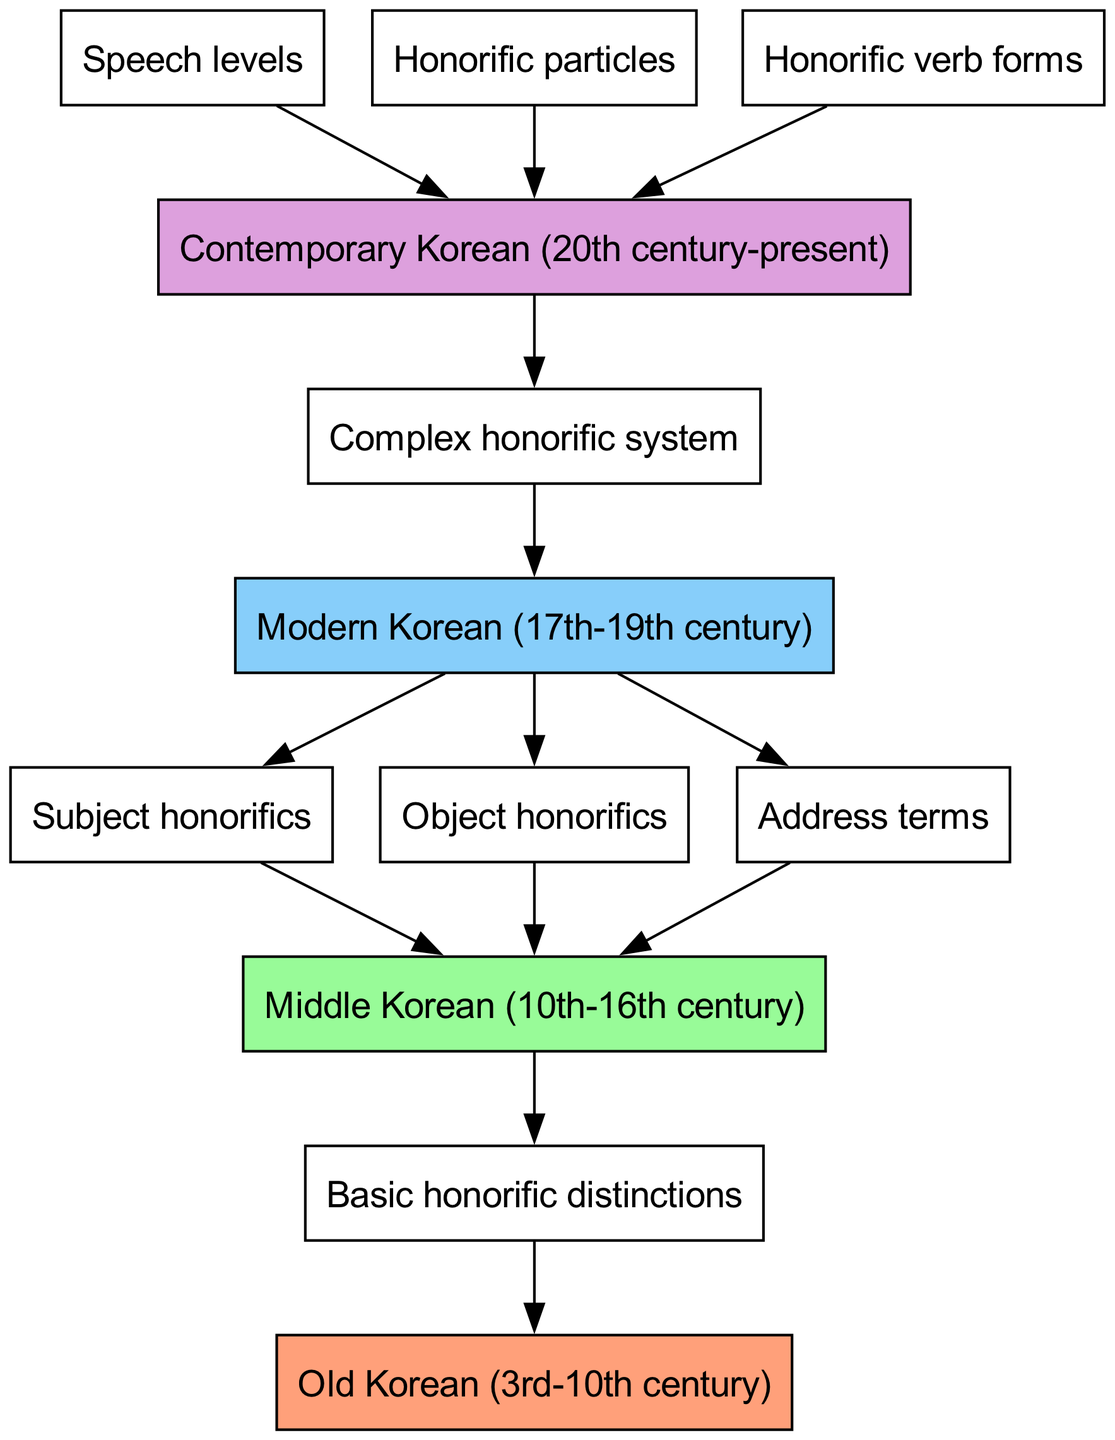What is the time period of Old Korean? Old Korean is identified within the time period of the 3rd to 10th century, which is shown at the top of the flow chart.
Answer: 3rd-10th century Which type of honorifics is introduced in Middle Korean? In Middle Korean, subject honorifics are introduced as shown by the direct connection from Middle Korean to subject honorifics in the diagram.
Answer: Subject honorifics How many distinct stages of development are there from Old Korean to Contemporary Korean? The diagram shows four distinct stages of development: Old Korean, Middle Korean, Modern Korean, and Contemporary Korean, thus totaling four stages.
Answer: 4 What type of honorific system emerges in Modern Korean? The complex honorific system emerges in Modern Korean as indicated by the arrow leading from Modern Korean to complex honorific system in the diagram.
Answer: Complex honorific system What are the two types of honorifics that branch out from Middle Korean? Middle Korean branches out into subject honorifics and object honorifics as indicated by the outgoing connections from Middle Korean, leading to those respective terms.
Answer: Subject and object honorifics What system is developed in Contemporary Korean that is linked to the complex honorific system? In Contemporary Korean, speech levels, honorific particles, and honorific verb forms are developed as indicated by the connections leading from the complex honorific system.
Answer: Speech levels, honorific particles, and honorific verb forms From which period to which period do the connections regarding honorific distinctions flow? The connections regarding honorific distinctions flow from Old Korean to Middle Korean, then to Modern Korean, and finally to Contemporary Korean, which encompasses the entire evolution of the honorific system over time.
Answer: Old Korean to Contemporary Korean How many honorific particles are developed in Contemporary Korean? According to the diagram, there is one connection leading to honorific particles from Contemporary Korean, indicating the existence of one unified system of honorific particles.
Answer: One 